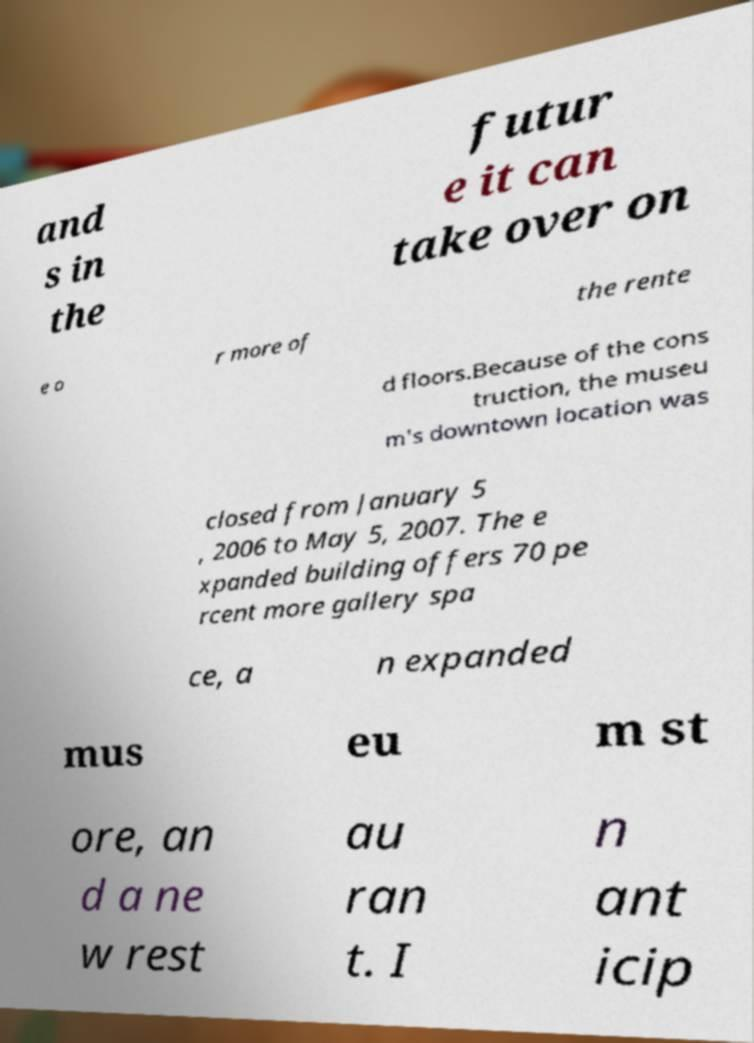For documentation purposes, I need the text within this image transcribed. Could you provide that? and s in the futur e it can take over on e o r more of the rente d floors.Because of the cons truction, the museu m's downtown location was closed from January 5 , 2006 to May 5, 2007. The e xpanded building offers 70 pe rcent more gallery spa ce, a n expanded mus eu m st ore, an d a ne w rest au ran t. I n ant icip 